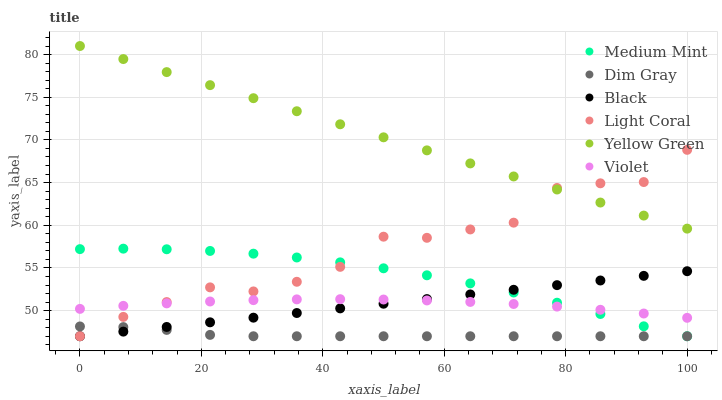Does Dim Gray have the minimum area under the curve?
Answer yes or no. Yes. Does Yellow Green have the maximum area under the curve?
Answer yes or no. Yes. Does Yellow Green have the minimum area under the curve?
Answer yes or no. No. Does Dim Gray have the maximum area under the curve?
Answer yes or no. No. Is Black the smoothest?
Answer yes or no. Yes. Is Light Coral the roughest?
Answer yes or no. Yes. Is Dim Gray the smoothest?
Answer yes or no. No. Is Dim Gray the roughest?
Answer yes or no. No. Does Medium Mint have the lowest value?
Answer yes or no. Yes. Does Yellow Green have the lowest value?
Answer yes or no. No. Does Yellow Green have the highest value?
Answer yes or no. Yes. Does Dim Gray have the highest value?
Answer yes or no. No. Is Dim Gray less than Violet?
Answer yes or no. Yes. Is Yellow Green greater than Medium Mint?
Answer yes or no. Yes. Does Black intersect Light Coral?
Answer yes or no. Yes. Is Black less than Light Coral?
Answer yes or no. No. Is Black greater than Light Coral?
Answer yes or no. No. Does Dim Gray intersect Violet?
Answer yes or no. No. 